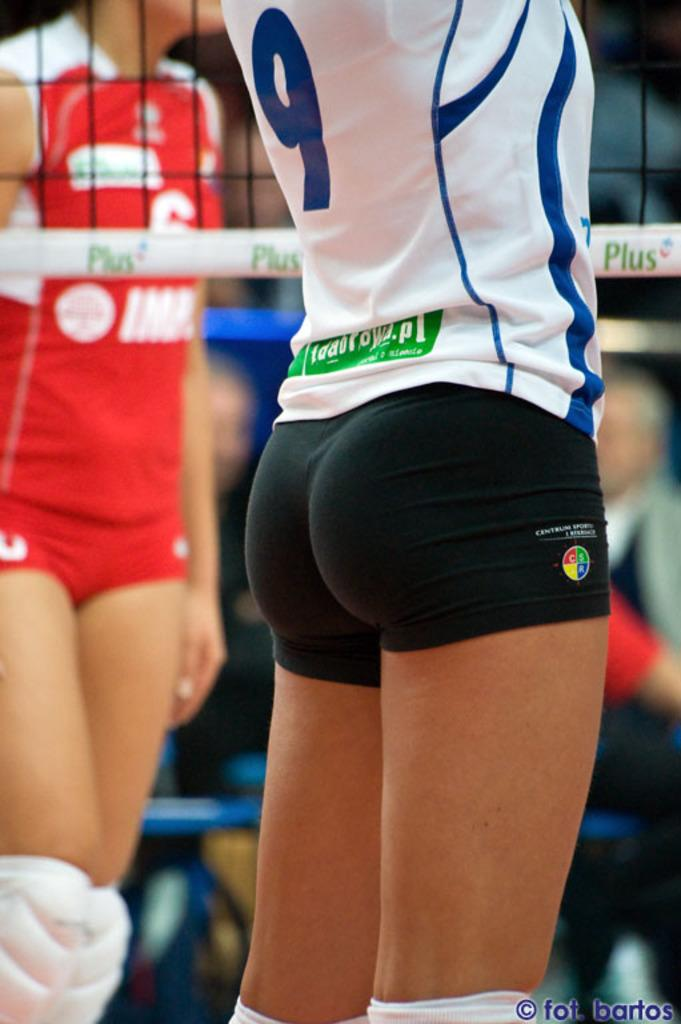<image>
Create a compact narrative representing the image presented. A girl wearing black shorts is player number 9. 